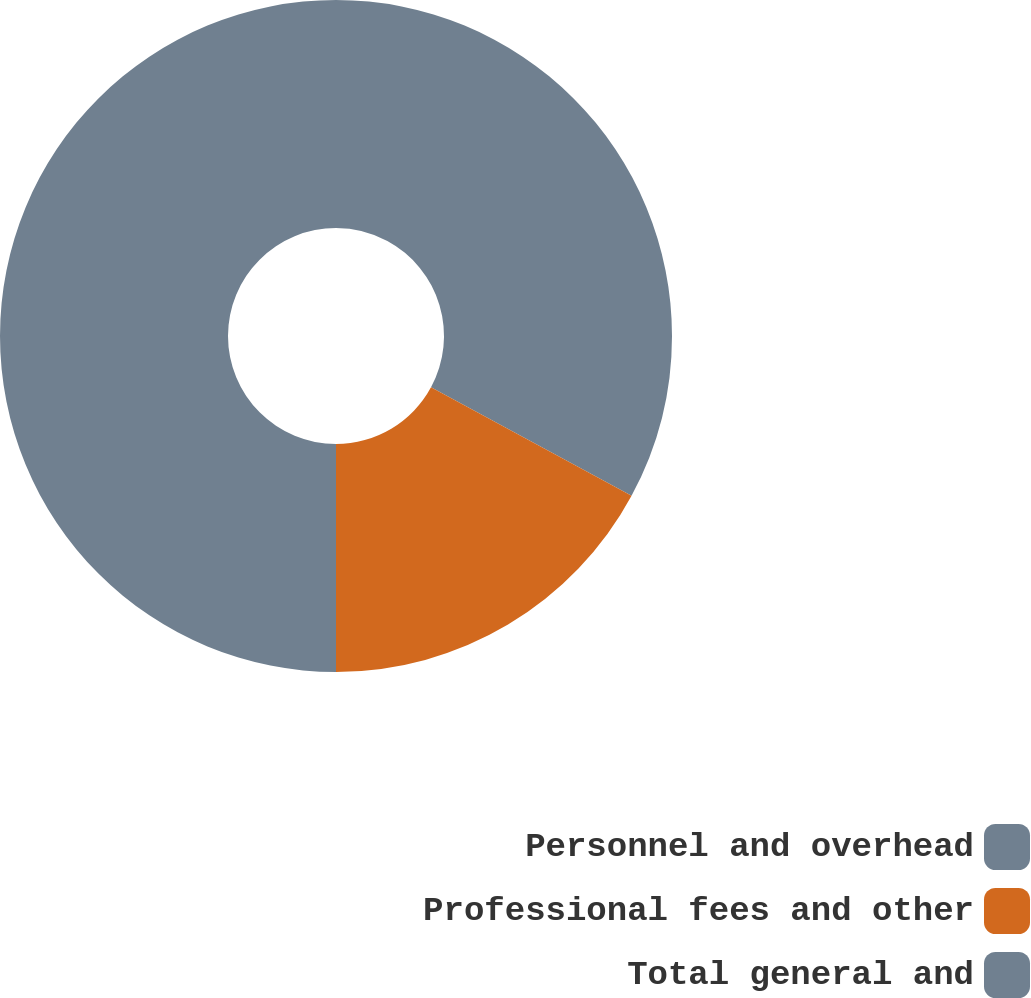<chart> <loc_0><loc_0><loc_500><loc_500><pie_chart><fcel>Personnel and overhead<fcel>Professional fees and other<fcel>Total general and<nl><fcel>32.89%<fcel>17.11%<fcel>50.0%<nl></chart> 